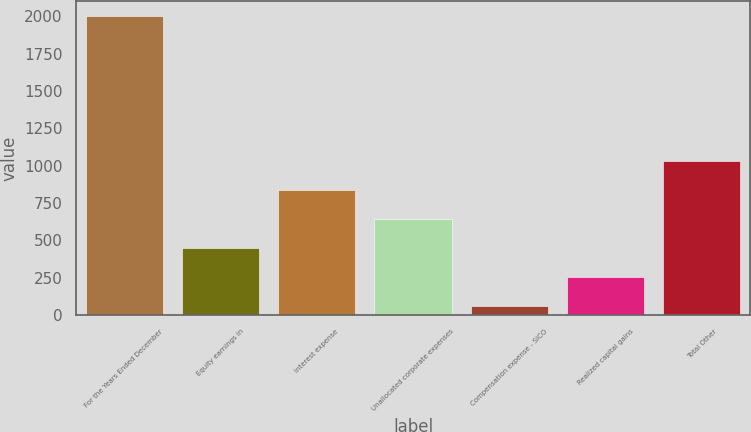Convert chart to OTSL. <chart><loc_0><loc_0><loc_500><loc_500><bar_chart><fcel>For the Years Ended December<fcel>Equity earnings in<fcel>Interest expense<fcel>Unallocated corporate expenses<fcel>Compensation expense - SICO<fcel>Realized capital gains<fcel>Total Other<nl><fcel>2004<fcel>450.4<fcel>838.8<fcel>644.6<fcel>62<fcel>256.2<fcel>1033<nl></chart> 